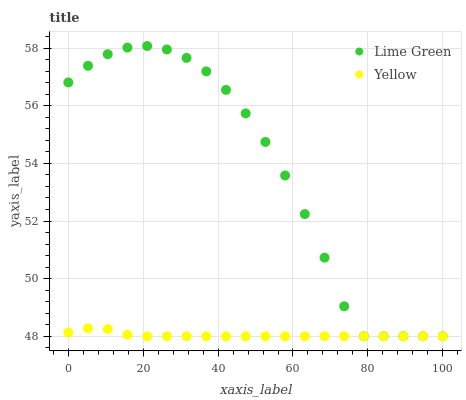Does Yellow have the minimum area under the curve?
Answer yes or no. Yes. Does Lime Green have the maximum area under the curve?
Answer yes or no. Yes. Does Yellow have the maximum area under the curve?
Answer yes or no. No. Is Yellow the smoothest?
Answer yes or no. Yes. Is Lime Green the roughest?
Answer yes or no. Yes. Is Yellow the roughest?
Answer yes or no. No. Does Lime Green have the lowest value?
Answer yes or no. Yes. Does Lime Green have the highest value?
Answer yes or no. Yes. Does Yellow have the highest value?
Answer yes or no. No. Does Lime Green intersect Yellow?
Answer yes or no. Yes. Is Lime Green less than Yellow?
Answer yes or no. No. Is Lime Green greater than Yellow?
Answer yes or no. No. 